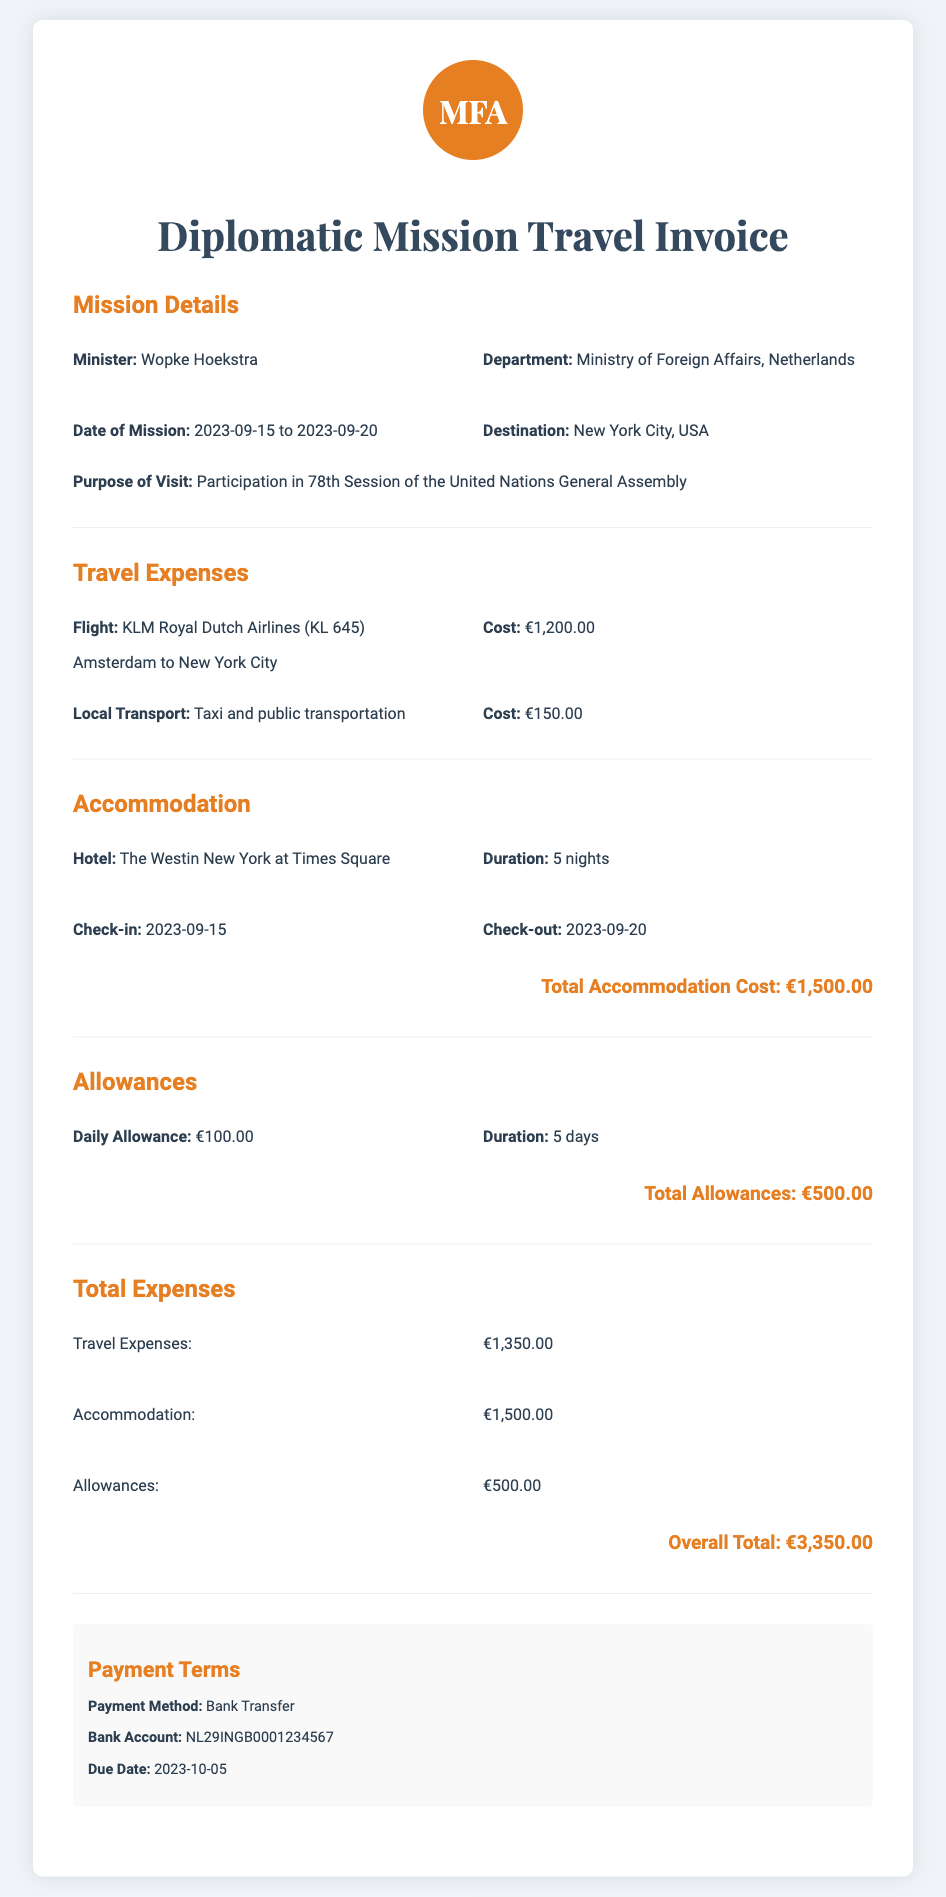what is the Minister's name? The Minister's name is listed in the mission details section of the document.
Answer: Wopke Hoekstra what was the destination of the mission? The destination of the mission is mentioned in the mission details.
Answer: New York City, USA what were the dates of the mission? The mission dates are provided in the mission details section of the document.
Answer: 2023-09-15 to 2023-09-20 how much was the total accommodation cost? The total accommodation cost is stated in the accommodation section of the document.
Answer: €1,500.00 what is the cost of the flight? The cost of the flight is specified in the travel expenses section.
Answer: €1,200.00 how many nights did the Minister stay at the hotel? The duration of the hotel stay is mentioned in the accommodation section.
Answer: 5 nights what is the due date for payment? The due date for payment can be found in the payment terms section.
Answer: 2023-10-05 what is the overall total of expenses? The overall total of expenses is summarized in the total expenses section.
Answer: €3,350.00 what is the daily allowance amount? The daily allowance amount is stated in the allowances section of the document.
Answer: €100.00 